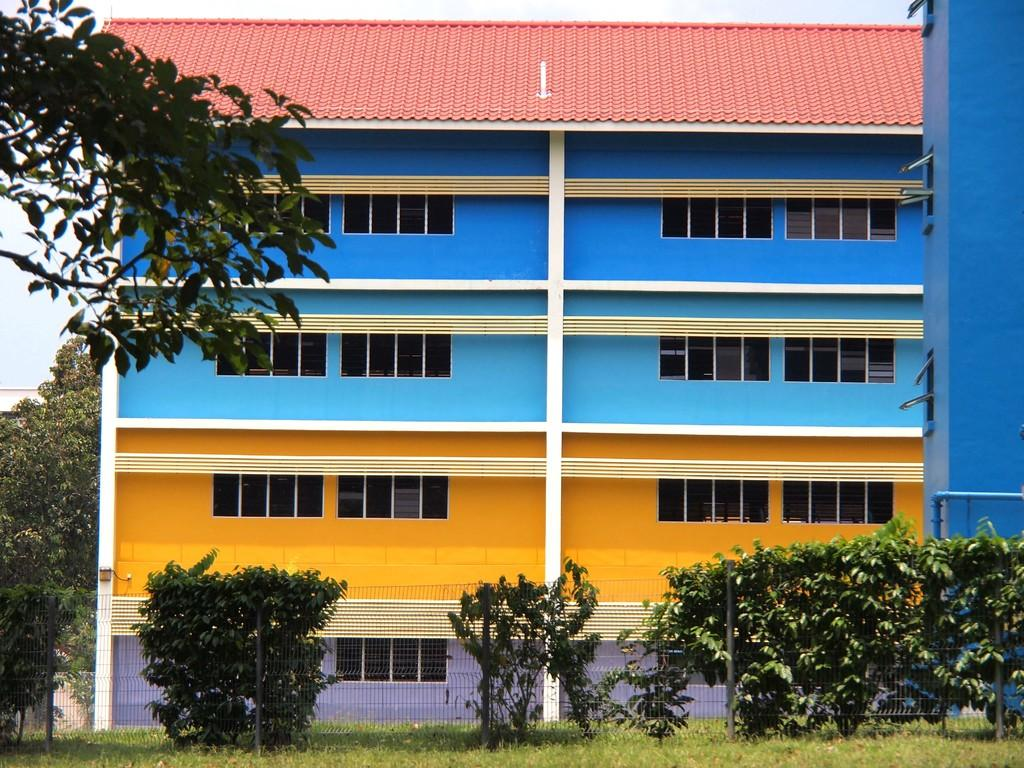What type of surface is visible in the image? There is grass on the surface in the image. What type of vegetation is present in the image? There are trees in the image. What type of barrier is present in the image? There is a metal fence in the image. What type of structures are visible in the image? There are buildings in the image. What is visible in the background of the image? The sky is visible in the background of the image. Can you see a squirrel climbing the chain in the image? There is no chain or squirrel present in the image. 